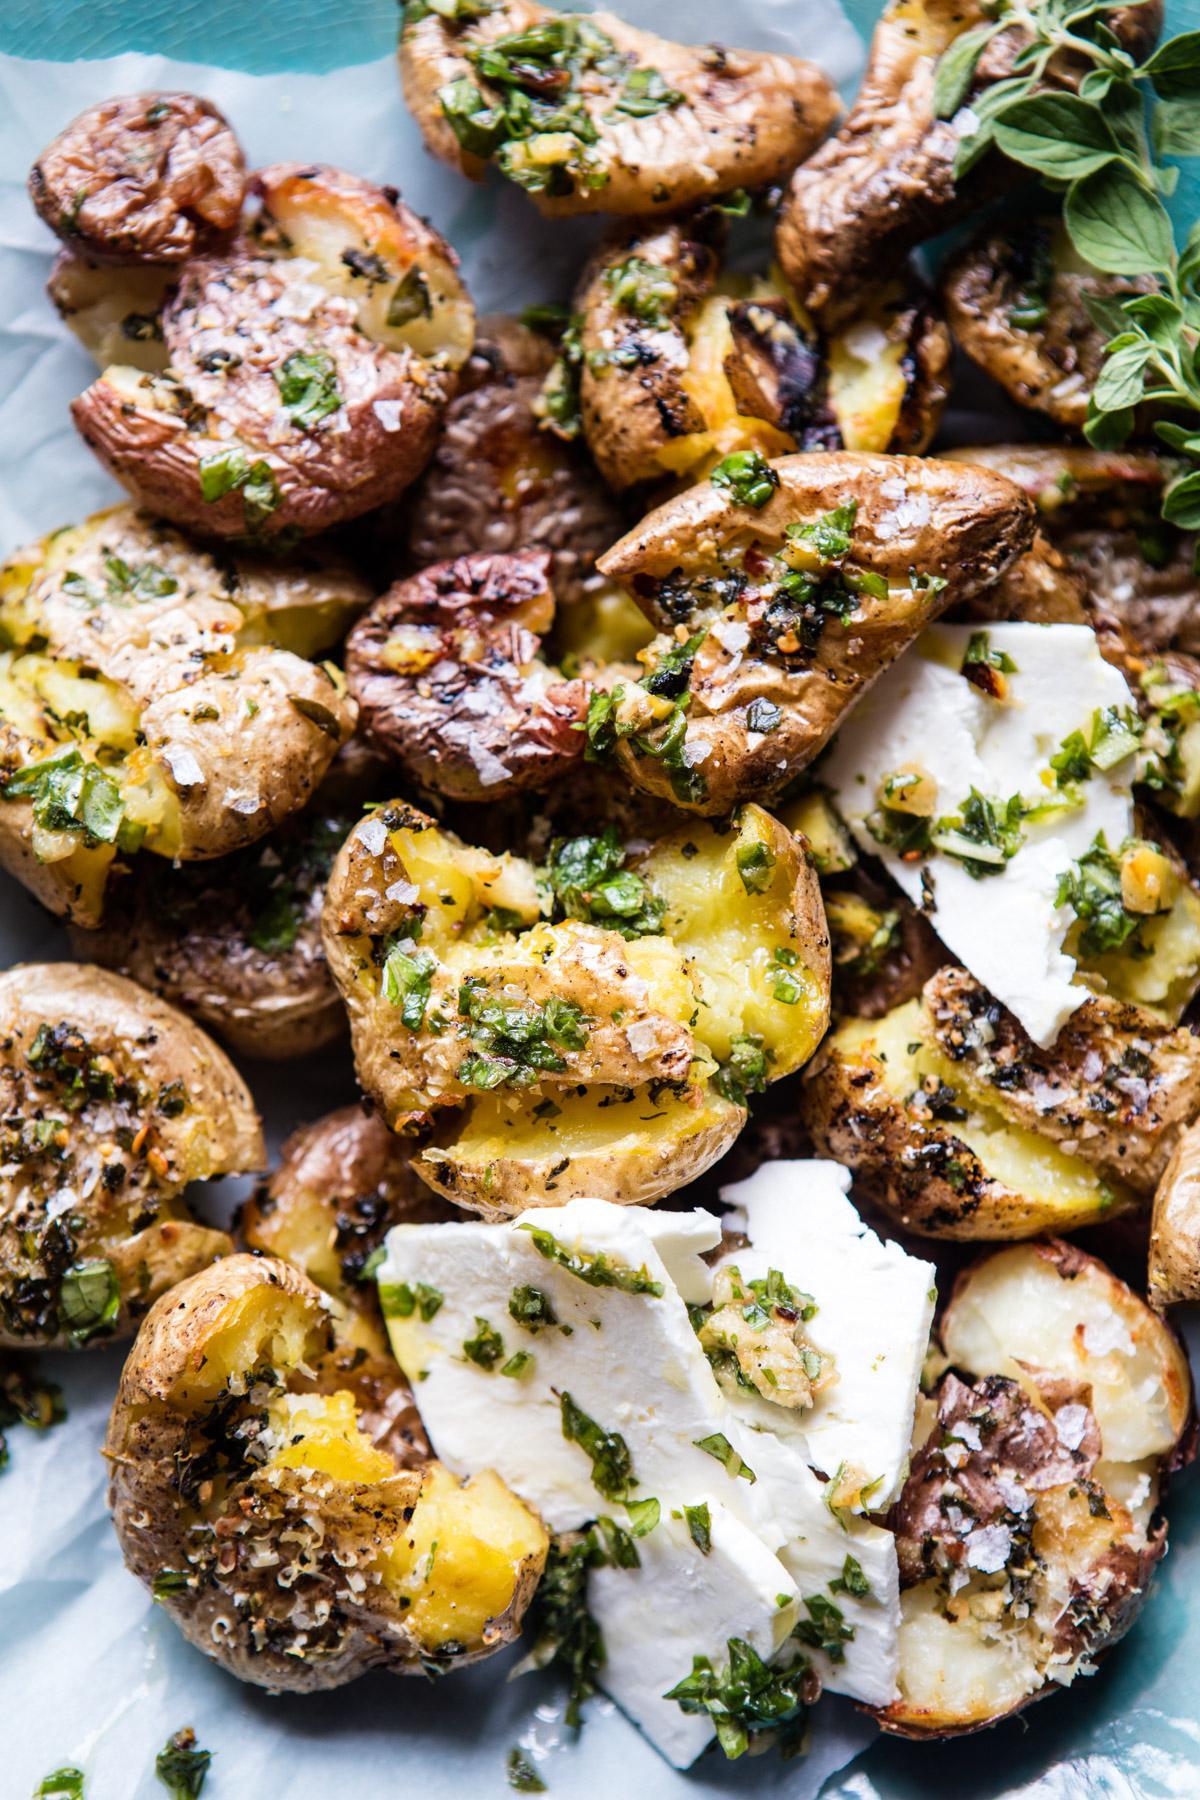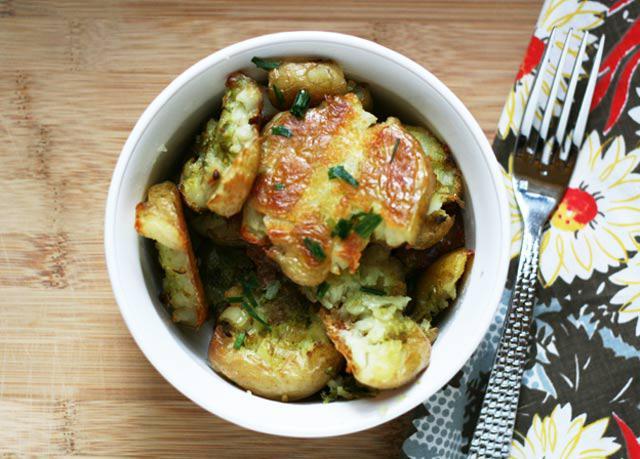The first image is the image on the left, the second image is the image on the right. For the images displayed, is the sentence "In one of the images, there is a piece of silverware on table next to the food dish, and no silverware in the food itself." factually correct? Answer yes or no. Yes. The first image is the image on the left, the second image is the image on the right. Considering the images on both sides, is "An item of silverware is on a napkin next to a round white bowl containing food." valid? Answer yes or no. Yes. 